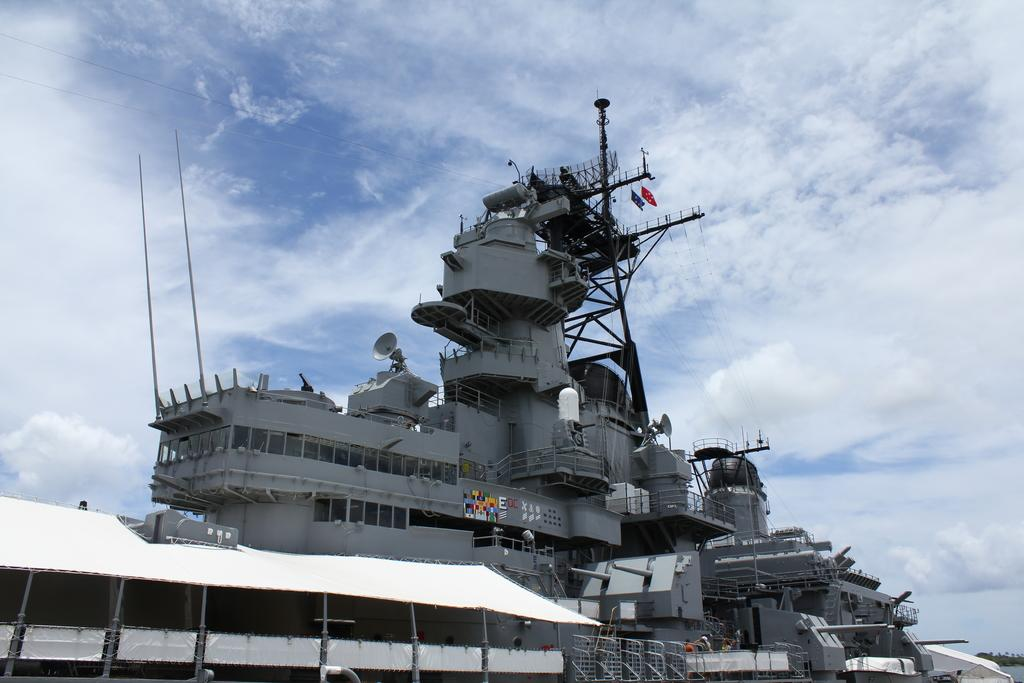What type of vehicle is present in the image? There is a battleship in the image. What structures can be seen in the image? There are poles, fences, and a tent visible in the image. What is attached to the metal wall in the image? There are posters on the metal wall in the image. What other objects can be seen in the image? There are flags in the image. What can be seen in the background of the image? There are trees, water, and clouds in the sky in the background of the image. What type of wood is used to build the good-bye sign in the image? There is no good-bye sign present in the image, and therefore no wood can be associated with it. How does the breath of the person in the image affect the battleship? There is no person present in the image, and thus their breath cannot affect the battleship. 